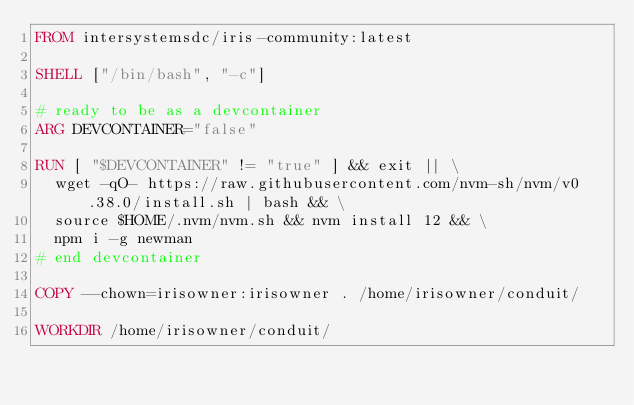Convert code to text. <code><loc_0><loc_0><loc_500><loc_500><_Dockerfile_>FROM intersystemsdc/iris-community:latest

SHELL ["/bin/bash", "-c"]

# ready to be as a devcontainer
ARG DEVCONTAINER="false"

RUN [ "$DEVCONTAINER" != "true" ] && exit || \
  wget -qO- https://raw.githubusercontent.com/nvm-sh/nvm/v0.38.0/install.sh | bash && \
  source $HOME/.nvm/nvm.sh && nvm install 12 && \
  npm i -g newman
# end devcontainer

COPY --chown=irisowner:irisowner . /home/irisowner/conduit/

WORKDIR /home/irisowner/conduit/
</code> 